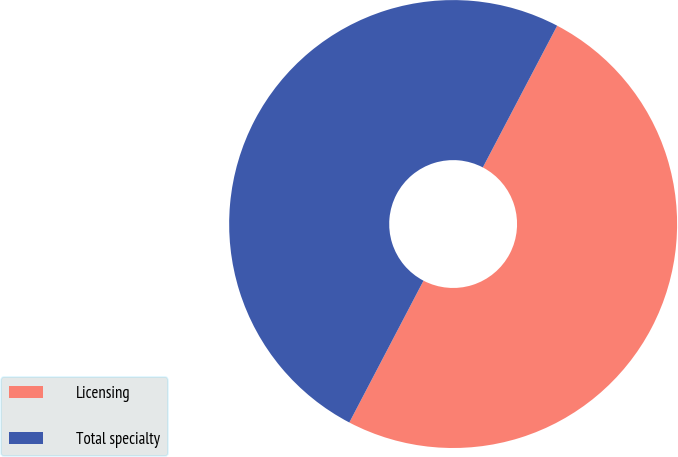<chart> <loc_0><loc_0><loc_500><loc_500><pie_chart><fcel>Licensing<fcel>Total specialty<nl><fcel>49.98%<fcel>50.02%<nl></chart> 